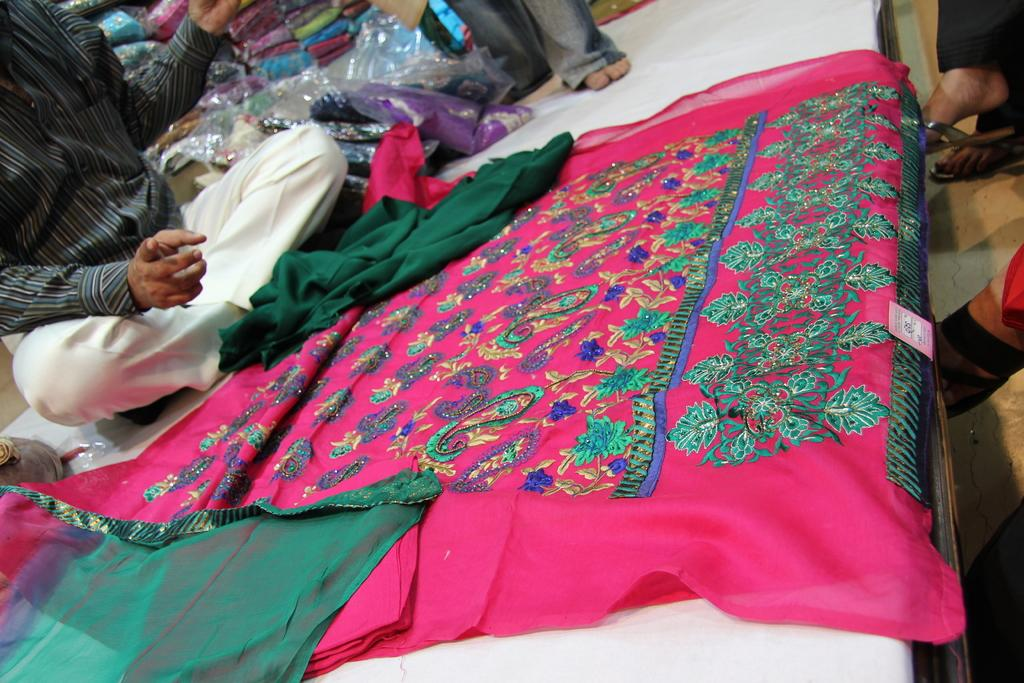What is the position of the man in the image? There is a man seated in the image. What is on the bed in the image? There is a saree on the bed. What is the other man in the image doing? There is another man standing in the image. Where are the sarees located in the image? There are sarees in the shelves. How many people are seated in the image? There are two people seated in the image. What type of flowers are arranged on the plate in the image? There is no plate or flowers present in the image. How does the hose help the people in the image? There is no hose present in the image, so it cannot help the people. 